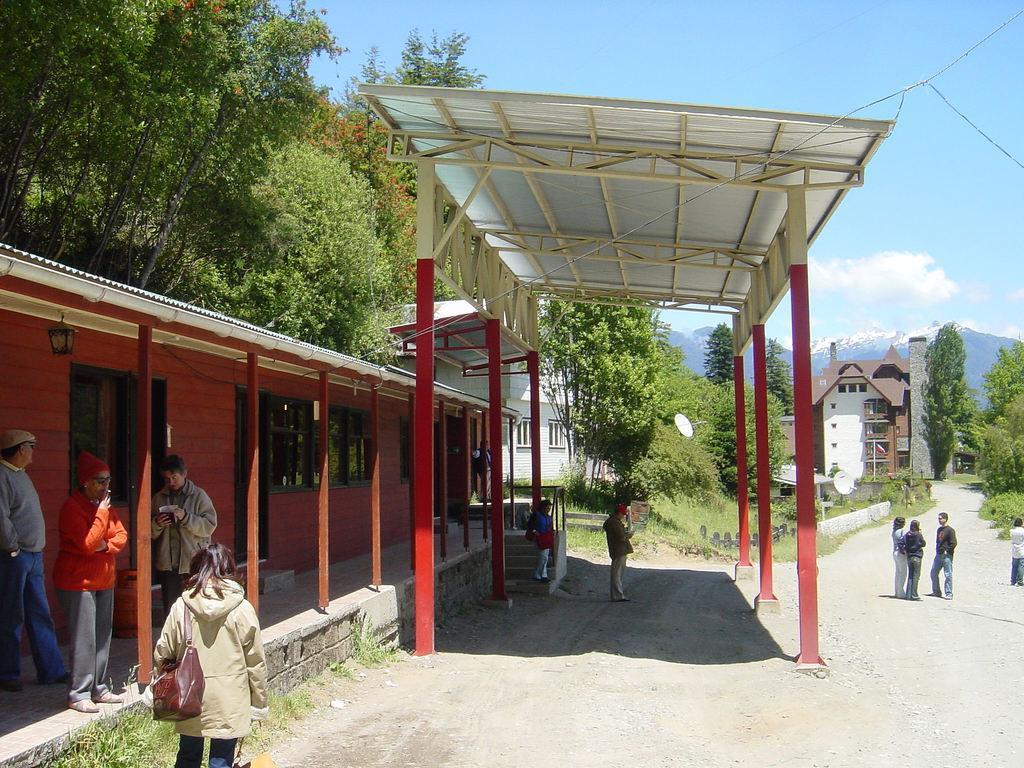Can you describe this image briefly? In this picture there is a red and white color shade house in the front side. Beside there is a small house and some men and women, standing and waiting. On the right side there is a road, two women and men is standing and talking. In the background there is a building and some trees. 